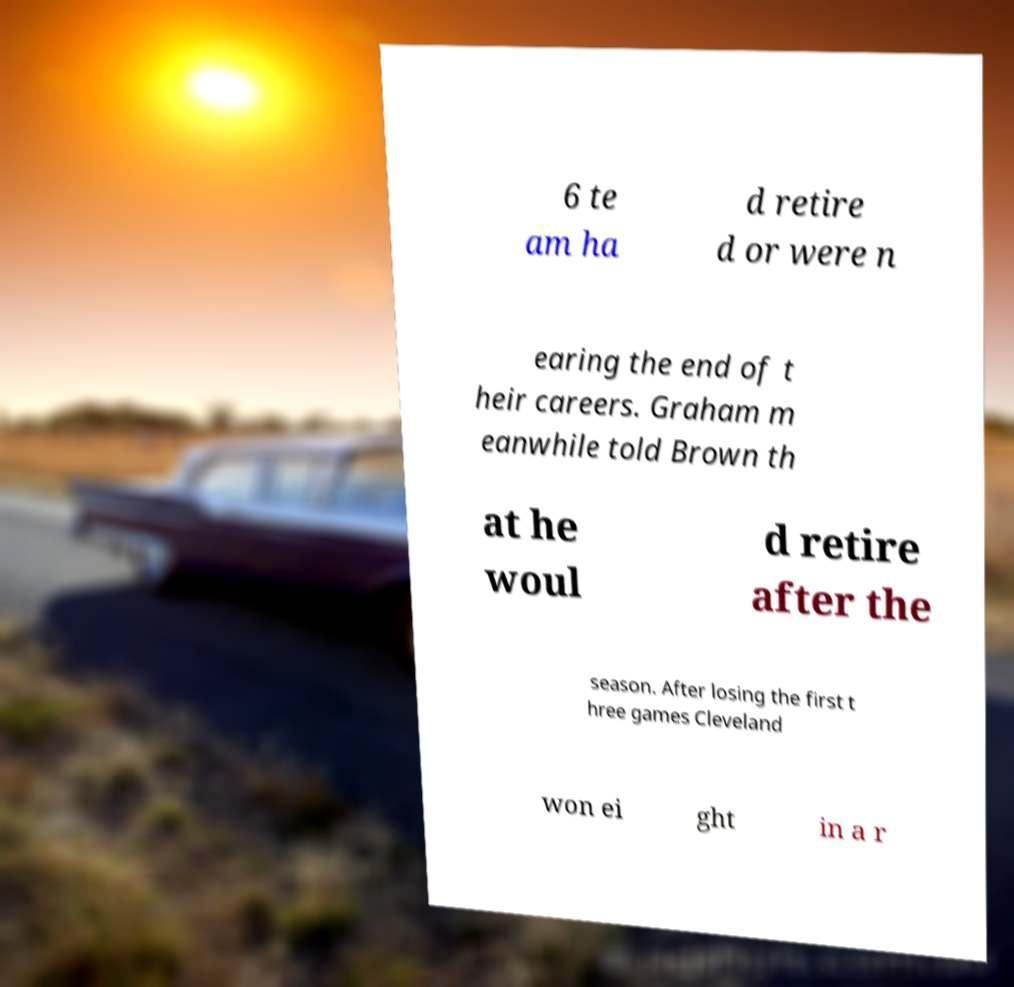What messages or text are displayed in this image? I need them in a readable, typed format. 6 te am ha d retire d or were n earing the end of t heir careers. Graham m eanwhile told Brown th at he woul d retire after the season. After losing the first t hree games Cleveland won ei ght in a r 